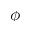Convert formula to latex. <formula><loc_0><loc_0><loc_500><loc_500>\phi</formula> 